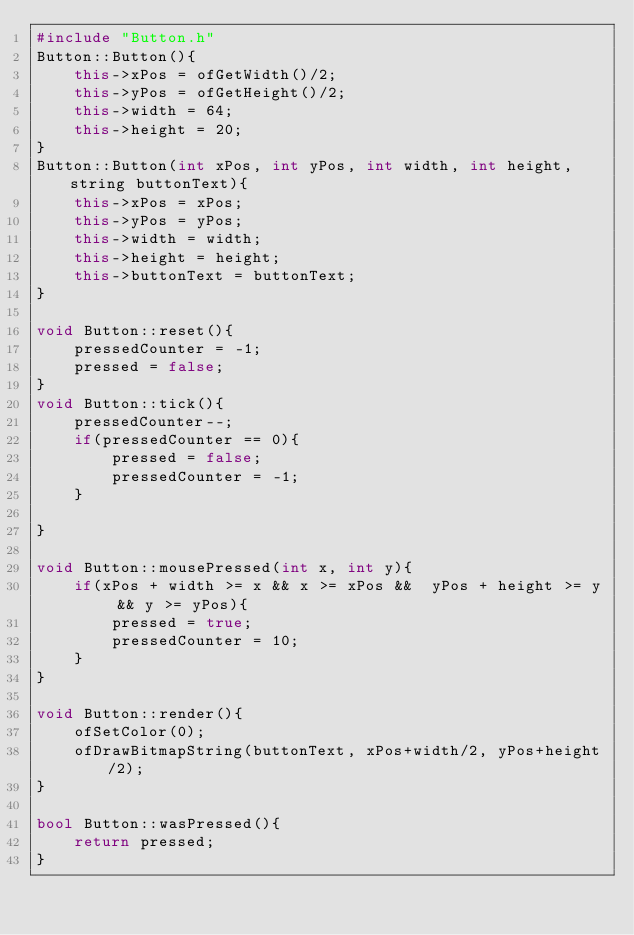Convert code to text. <code><loc_0><loc_0><loc_500><loc_500><_C++_>#include "Button.h"
Button::Button(){
    this->xPos = ofGetWidth()/2;
    this->yPos = ofGetHeight()/2;
    this->width = 64;
    this->height = 20; 
}
Button::Button(int xPos, int yPos, int width, int height, string buttonText){
    this->xPos = xPos;
    this->yPos = yPos;
    this->width = width;
    this->height = height;
    this->buttonText = buttonText;
}

void Button::reset(){
    pressedCounter = -1;
    pressed = false;
}
void Button::tick(){
    pressedCounter--;
    if(pressedCounter == 0){
        pressed = false;
        pressedCounter = -1;
    }

}

void Button::mousePressed(int x, int y){
    if(xPos + width >= x && x >= xPos &&  yPos + height >= y && y >= yPos){
        pressed = true;
        pressedCounter = 10;
    }
}

void Button::render(){
    ofSetColor(0);
    ofDrawBitmapString(buttonText, xPos+width/2, yPos+height/2);
}

bool Button::wasPressed(){
    return pressed;
}</code> 